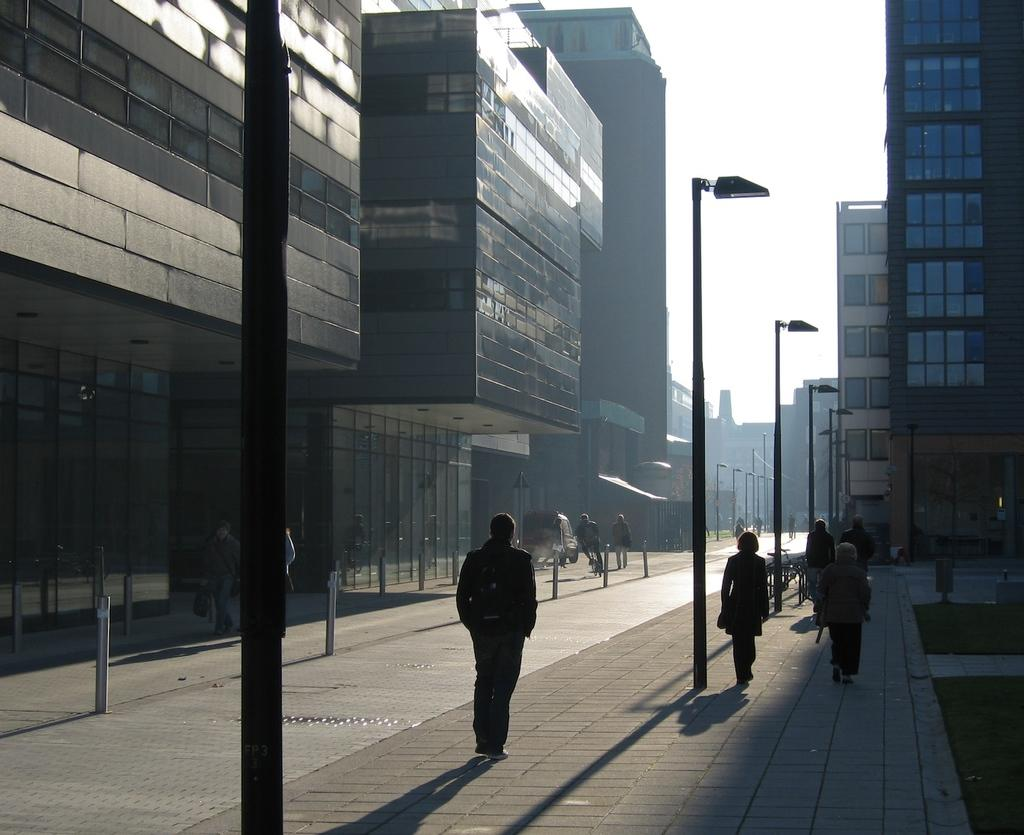What type of structures can be seen in the image? There are buildings in the image. What type of lighting is present along the streets in the image? There are street lights in the image. What are the people in the image doing? People are walking on a footpath in the image. What is visible in the background of the image? The sky is visible in the image. What type of health issues are the people in the image experiencing due to the sleet? There is no mention of sleet or any health issues in the image. How does the wealth of the people in the image affect their choice of footwear? There is no information about the wealth of the people in the image, nor is there any indication of their footwear. 